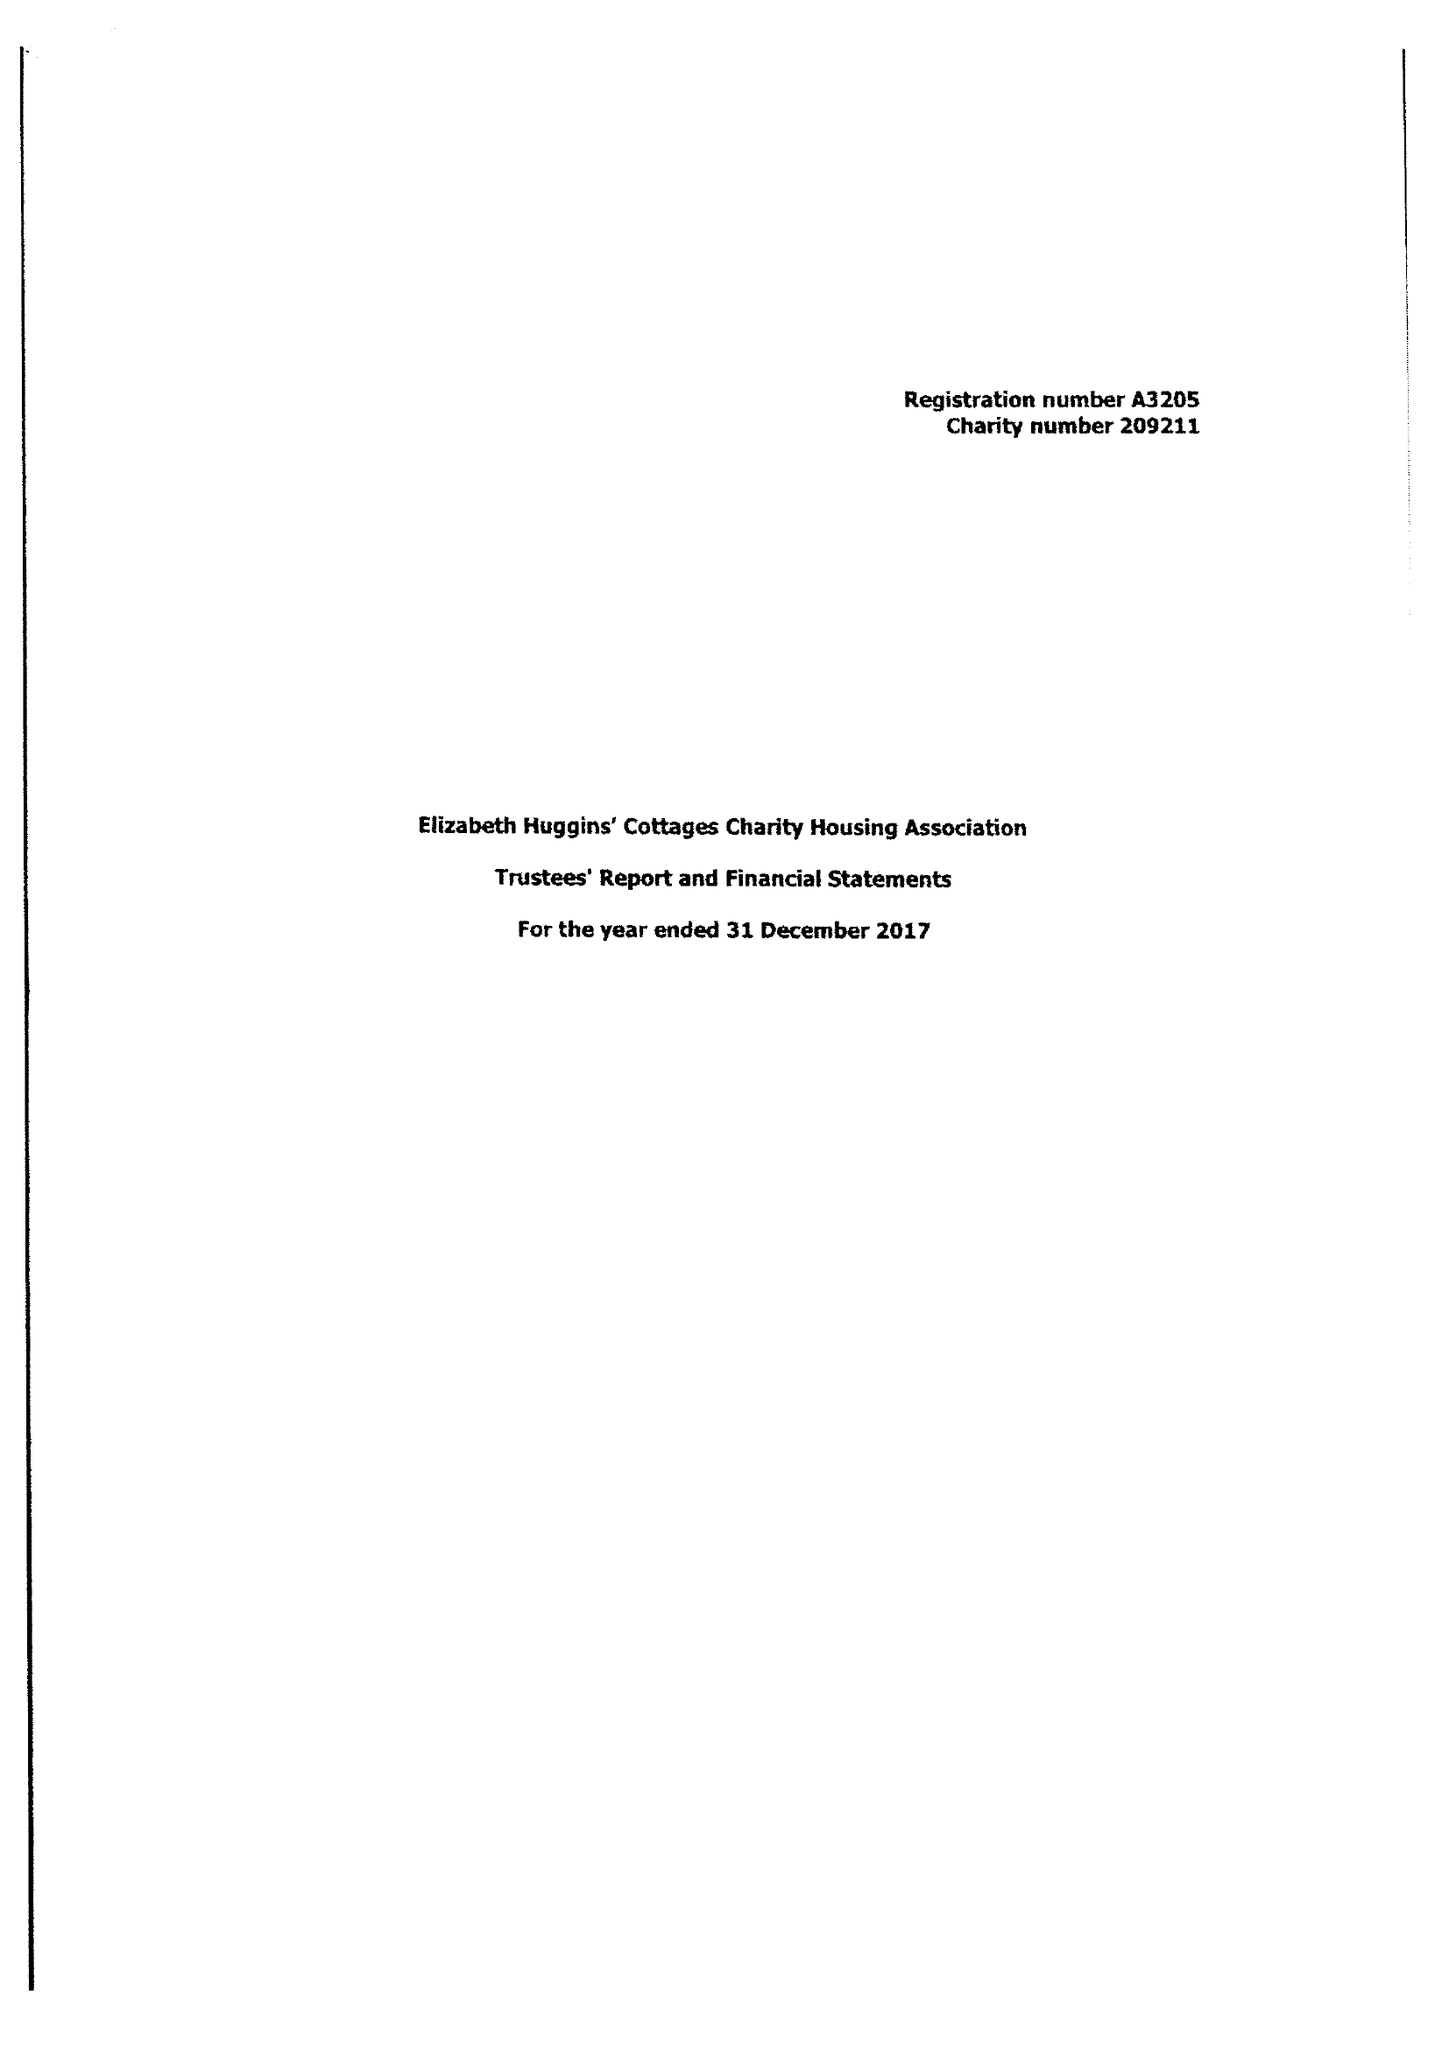What is the value for the address__post_town?
Answer the question using a single word or phrase. GRAVESEND 